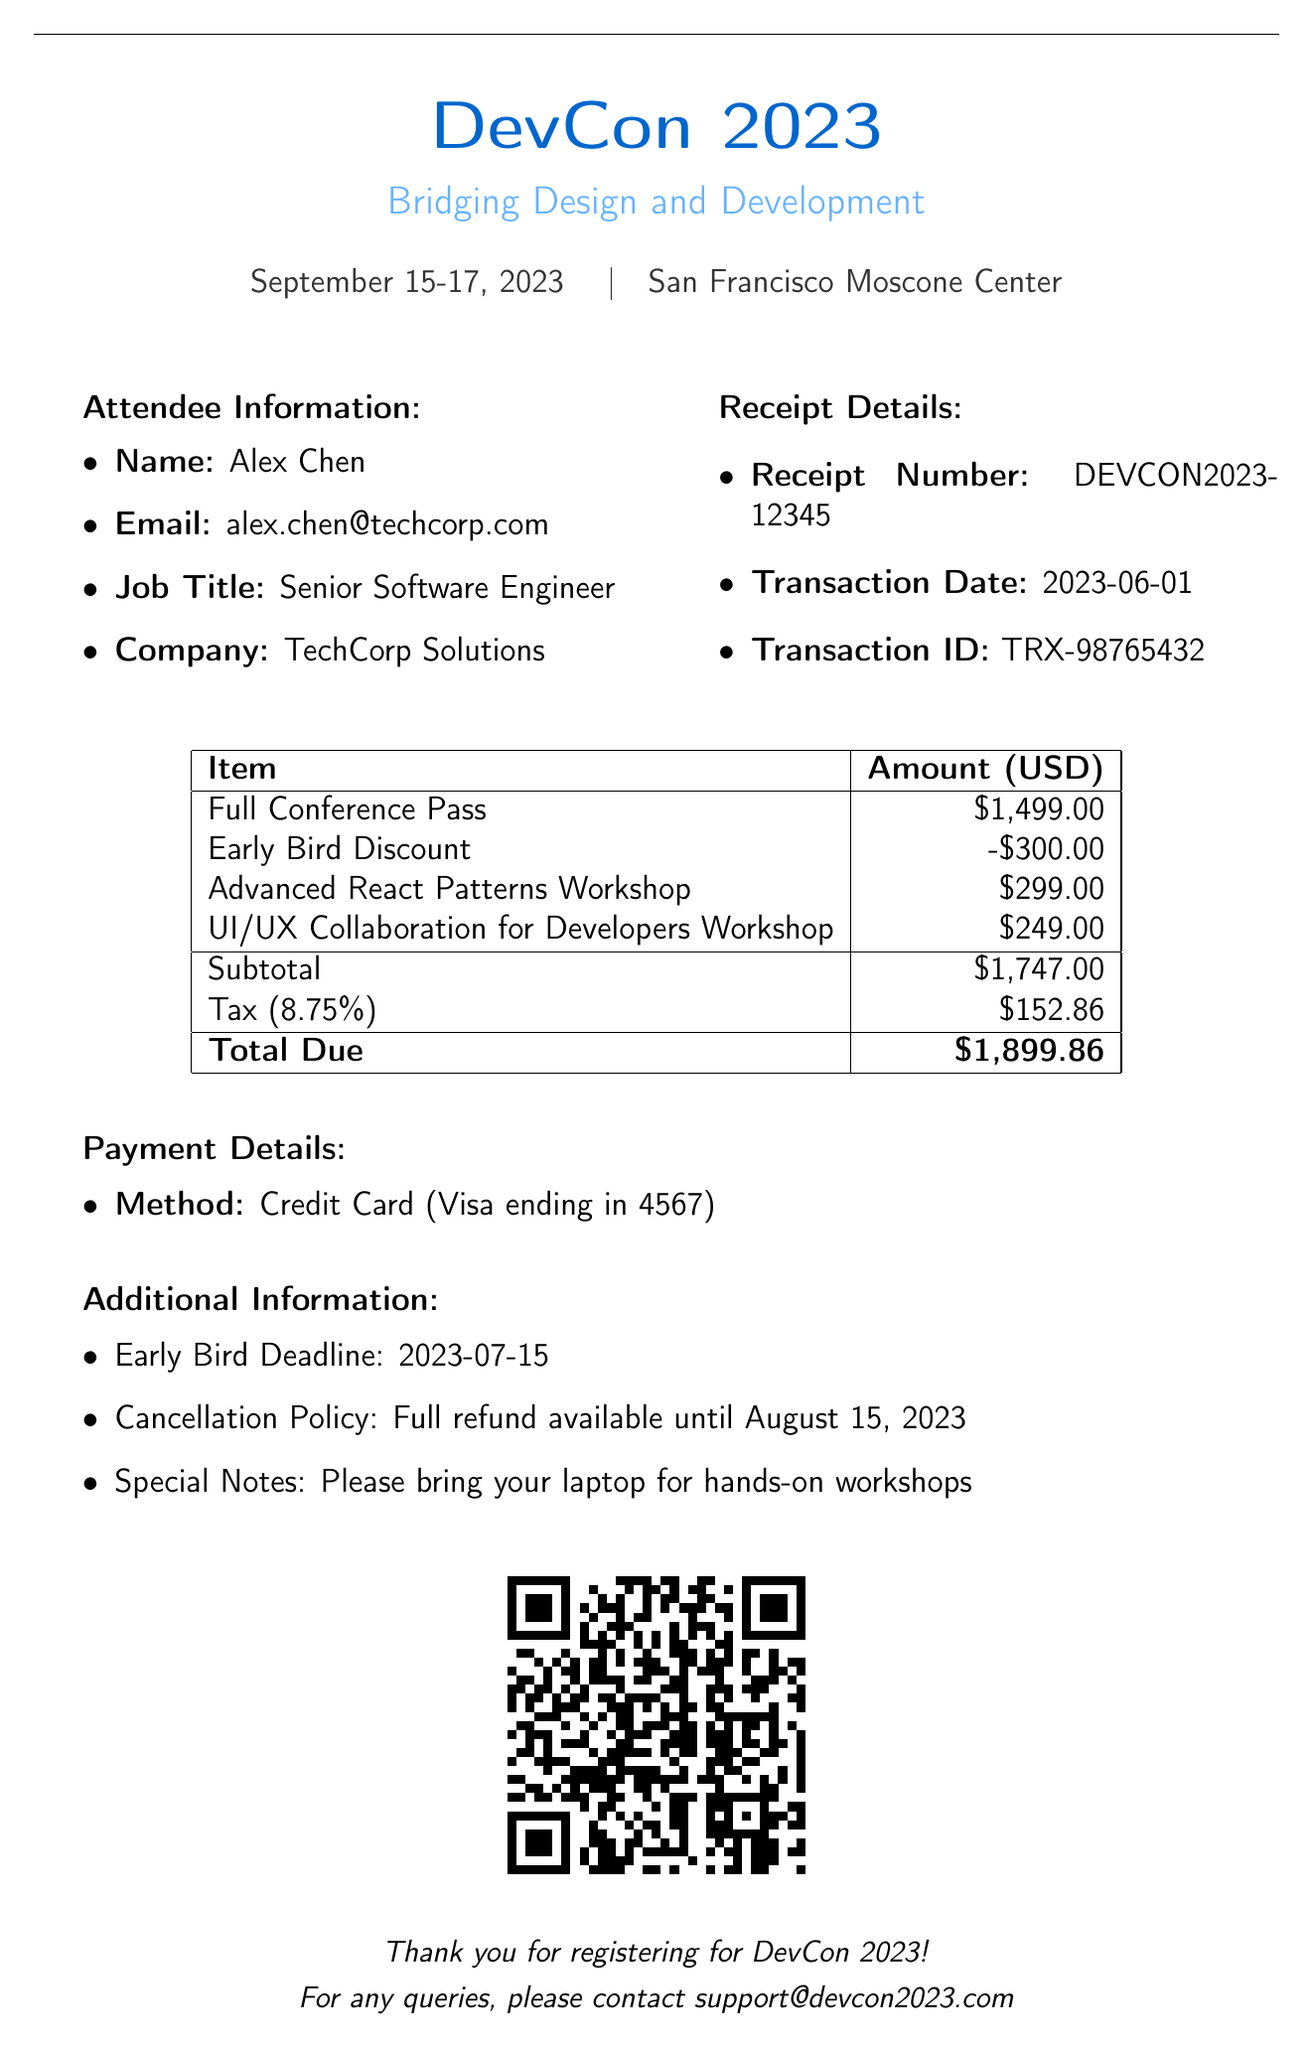what is the name of the conference? The name of the conference is mentioned in the document as "DevCon 2023: Bridging Design and Development".
Answer: DevCon 2023: Bridging Design and Development what is the transaction date? The date of the transaction can be found in the payment details section of the document.
Answer: 2023-06-01 who is the attendee? The attendee's name is specified in the attendee information section of the document.
Answer: Alex Chen what is the early bird discount amount? The early bird discount amount is listed in the pricing breakdown of the document.
Answer: $300.00 what is the total due amount? The total due amount is summarized at the end of the pricing section.
Answer: $1,899.86 how much is the workshop fee for the Advanced React Patterns Workshop? The fee for the specific workshop is detailed in the workshop fees breakdown of the document.
Answer: $299.00 what is the cancellation policy? The cancellation policy is stated in the additional information section of the document.
Answer: Full refund available until August 15, 2023 when is the early bird deadline? The early bird deadline is provided in the additional information section of the document.
Answer: 2023-07-15 what payment method was used? The payment method is specified in the payment details section of the document.
Answer: Credit Card 